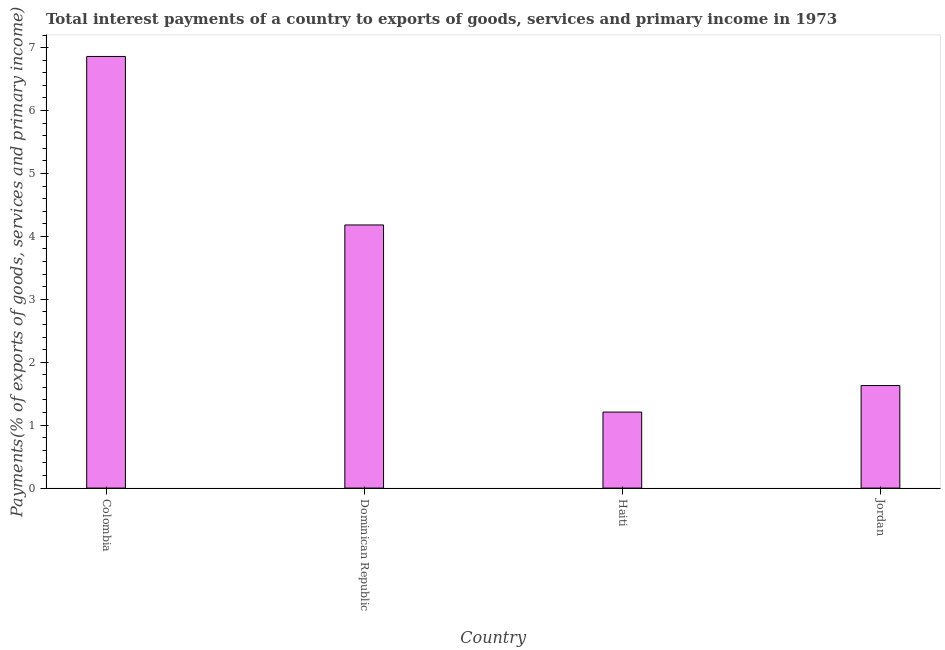Does the graph contain any zero values?
Your answer should be compact. No. What is the title of the graph?
Your answer should be compact. Total interest payments of a country to exports of goods, services and primary income in 1973. What is the label or title of the Y-axis?
Your answer should be very brief. Payments(% of exports of goods, services and primary income). What is the total interest payments on external debt in Dominican Republic?
Your answer should be very brief. 4.18. Across all countries, what is the maximum total interest payments on external debt?
Make the answer very short. 6.86. Across all countries, what is the minimum total interest payments on external debt?
Offer a terse response. 1.21. In which country was the total interest payments on external debt minimum?
Provide a short and direct response. Haiti. What is the sum of the total interest payments on external debt?
Your answer should be compact. 13.88. What is the difference between the total interest payments on external debt in Colombia and Jordan?
Offer a terse response. 5.23. What is the average total interest payments on external debt per country?
Ensure brevity in your answer.  3.47. What is the median total interest payments on external debt?
Ensure brevity in your answer.  2.91. What is the ratio of the total interest payments on external debt in Dominican Republic to that in Haiti?
Provide a succinct answer. 3.46. What is the difference between the highest and the second highest total interest payments on external debt?
Your answer should be compact. 2.68. Is the sum of the total interest payments on external debt in Haiti and Jordan greater than the maximum total interest payments on external debt across all countries?
Offer a terse response. No. What is the difference between the highest and the lowest total interest payments on external debt?
Provide a succinct answer. 5.65. In how many countries, is the total interest payments on external debt greater than the average total interest payments on external debt taken over all countries?
Your response must be concise. 2. How many bars are there?
Offer a very short reply. 4. Are all the bars in the graph horizontal?
Provide a succinct answer. No. What is the difference between two consecutive major ticks on the Y-axis?
Provide a succinct answer. 1. What is the Payments(% of exports of goods, services and primary income) of Colombia?
Ensure brevity in your answer.  6.86. What is the Payments(% of exports of goods, services and primary income) of Dominican Republic?
Ensure brevity in your answer.  4.18. What is the Payments(% of exports of goods, services and primary income) in Haiti?
Your answer should be very brief. 1.21. What is the Payments(% of exports of goods, services and primary income) of Jordan?
Provide a succinct answer. 1.63. What is the difference between the Payments(% of exports of goods, services and primary income) in Colombia and Dominican Republic?
Your answer should be compact. 2.68. What is the difference between the Payments(% of exports of goods, services and primary income) in Colombia and Haiti?
Offer a terse response. 5.65. What is the difference between the Payments(% of exports of goods, services and primary income) in Colombia and Jordan?
Give a very brief answer. 5.23. What is the difference between the Payments(% of exports of goods, services and primary income) in Dominican Republic and Haiti?
Offer a very short reply. 2.97. What is the difference between the Payments(% of exports of goods, services and primary income) in Dominican Republic and Jordan?
Ensure brevity in your answer.  2.55. What is the difference between the Payments(% of exports of goods, services and primary income) in Haiti and Jordan?
Your answer should be compact. -0.42. What is the ratio of the Payments(% of exports of goods, services and primary income) in Colombia to that in Dominican Republic?
Provide a short and direct response. 1.64. What is the ratio of the Payments(% of exports of goods, services and primary income) in Colombia to that in Haiti?
Make the answer very short. 5.68. What is the ratio of the Payments(% of exports of goods, services and primary income) in Colombia to that in Jordan?
Your answer should be compact. 4.21. What is the ratio of the Payments(% of exports of goods, services and primary income) in Dominican Republic to that in Haiti?
Offer a terse response. 3.46. What is the ratio of the Payments(% of exports of goods, services and primary income) in Dominican Republic to that in Jordan?
Your answer should be very brief. 2.57. What is the ratio of the Payments(% of exports of goods, services and primary income) in Haiti to that in Jordan?
Make the answer very short. 0.74. 